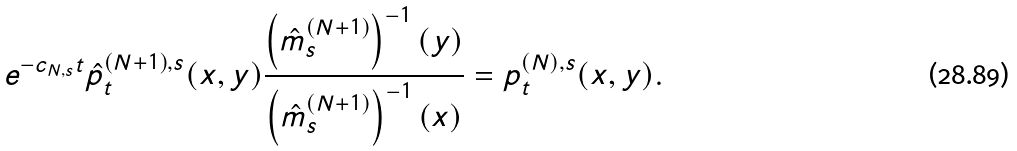Convert formula to latex. <formula><loc_0><loc_0><loc_500><loc_500>e ^ { - c _ { N , s } t } \hat { p } _ { t } ^ { ( N + 1 ) , s } ( x , y ) \frac { \left ( \hat { m } _ { s } ^ { ( N + 1 ) } \right ) ^ { - 1 } ( y ) } { \left ( \hat { m } _ { s } ^ { ( N + 1 ) } \right ) ^ { - 1 } ( x ) } = p _ { t } ^ { ( N ) , s } ( x , y ) .</formula> 